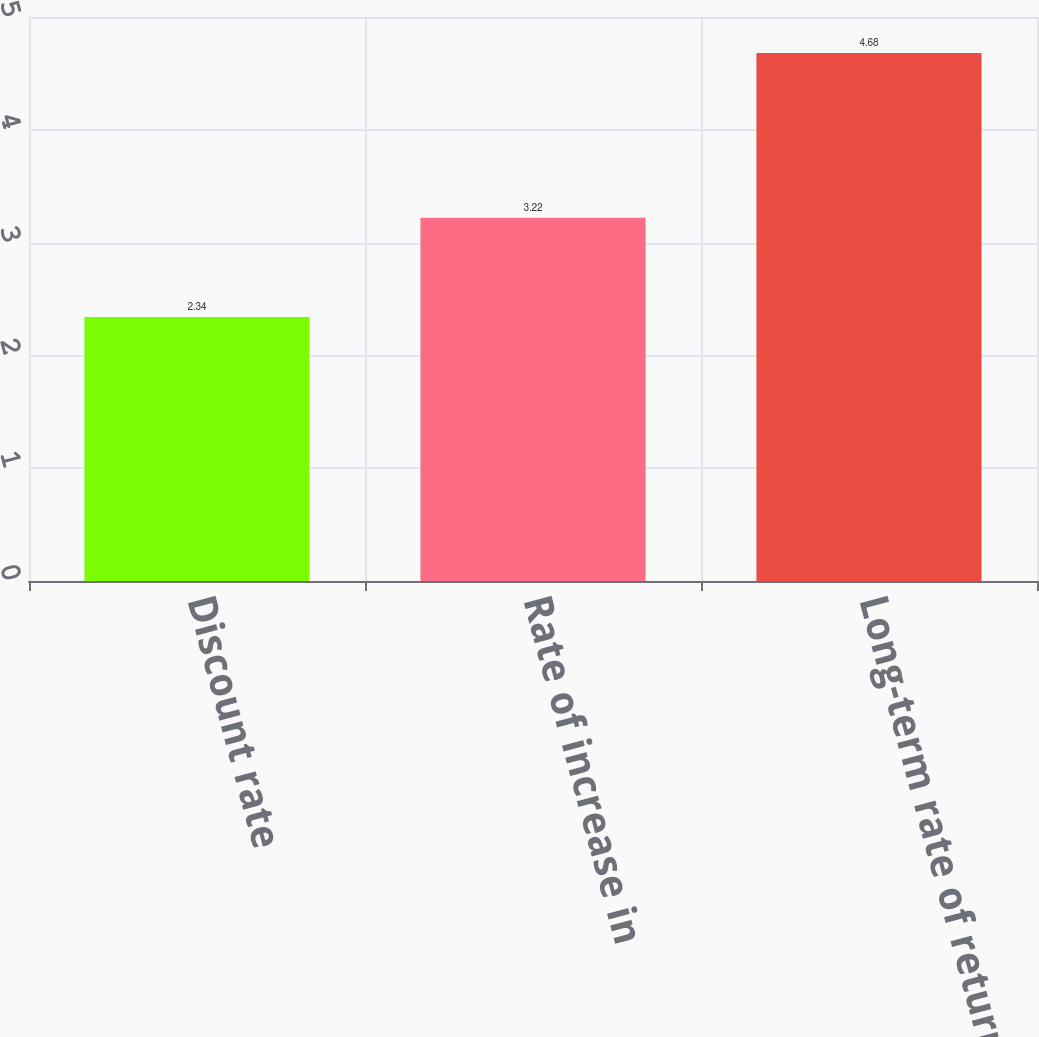<chart> <loc_0><loc_0><loc_500><loc_500><bar_chart><fcel>Discount rate<fcel>Rate of increase in<fcel>Long-term rate of return on<nl><fcel>2.34<fcel>3.22<fcel>4.68<nl></chart> 